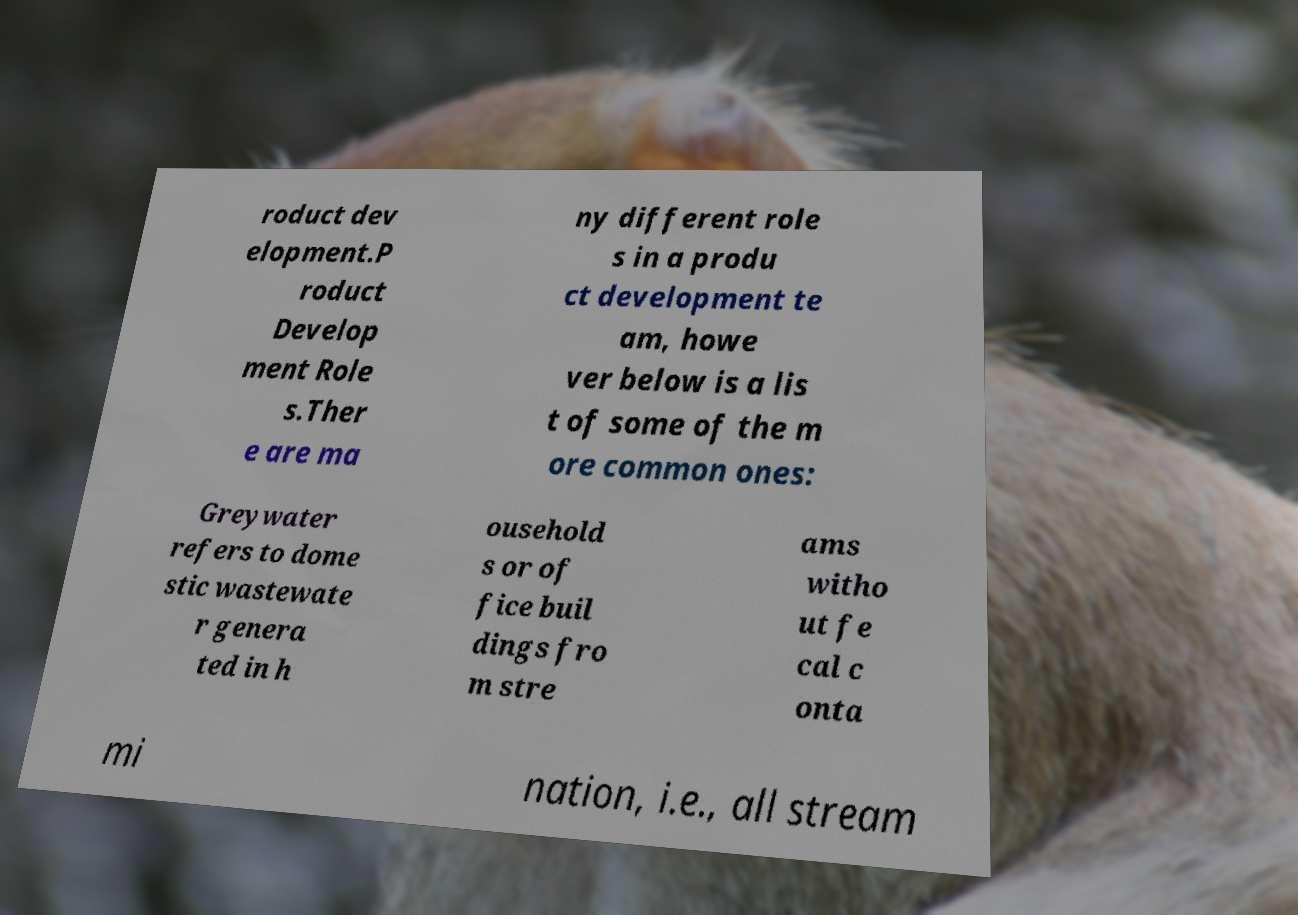For documentation purposes, I need the text within this image transcribed. Could you provide that? roduct dev elopment.P roduct Develop ment Role s.Ther e are ma ny different role s in a produ ct development te am, howe ver below is a lis t of some of the m ore common ones: Greywater refers to dome stic wastewate r genera ted in h ousehold s or of fice buil dings fro m stre ams witho ut fe cal c onta mi nation, i.e., all stream 